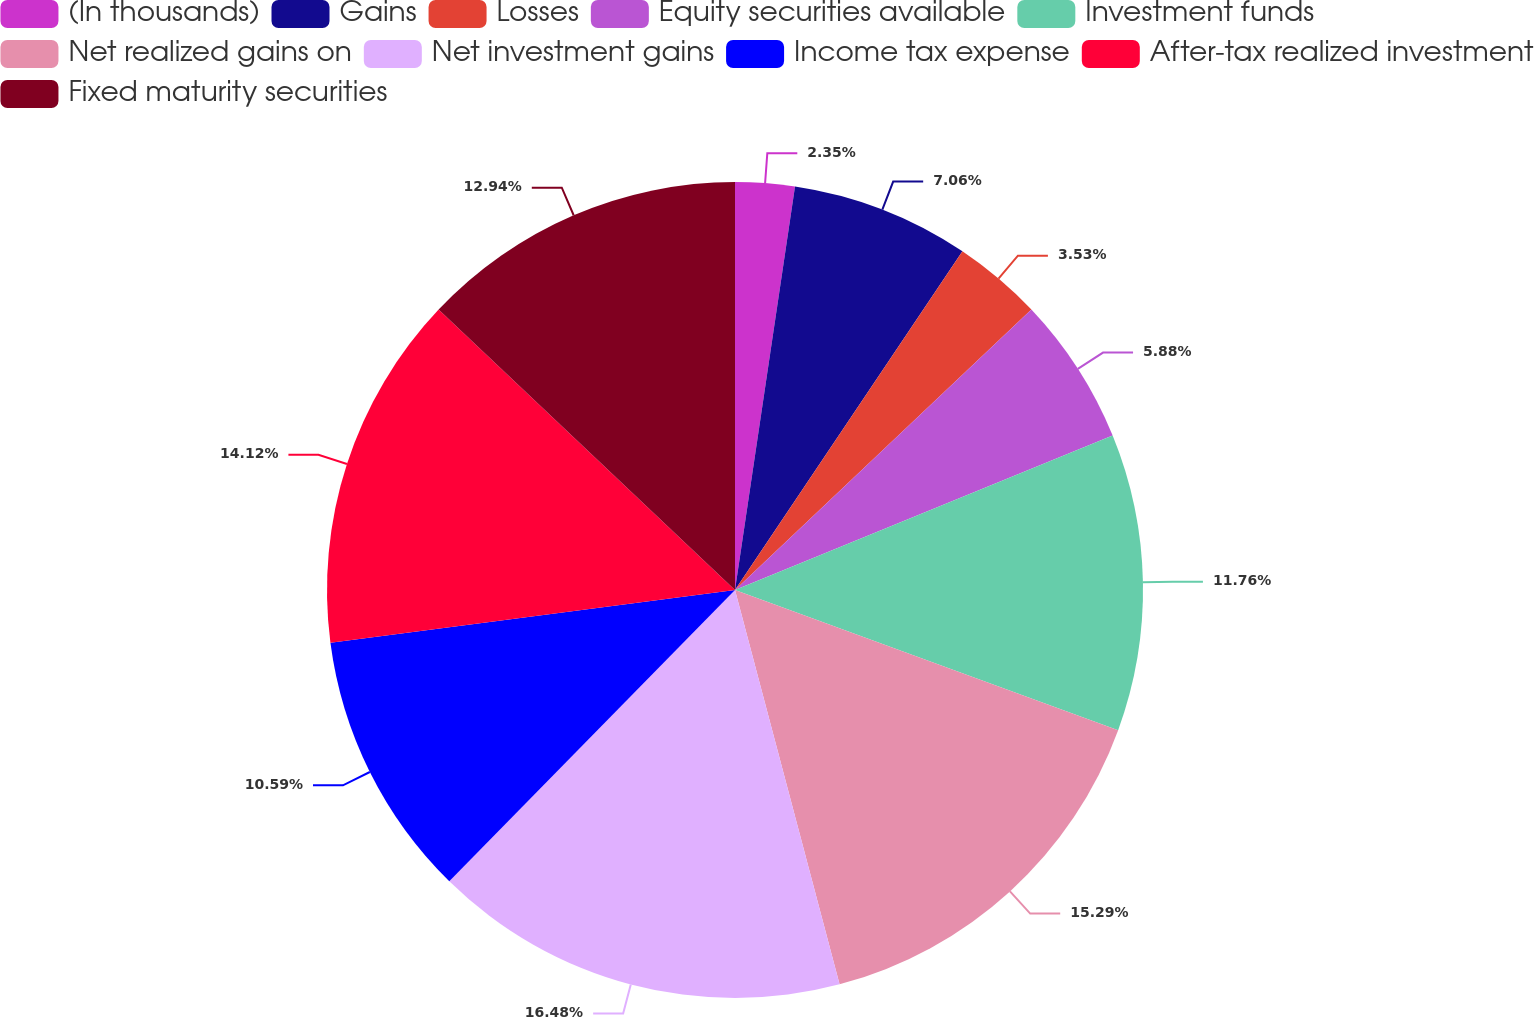Convert chart to OTSL. <chart><loc_0><loc_0><loc_500><loc_500><pie_chart><fcel>(In thousands)<fcel>Gains<fcel>Losses<fcel>Equity securities available<fcel>Investment funds<fcel>Net realized gains on<fcel>Net investment gains<fcel>Income tax expense<fcel>After-tax realized investment<fcel>Fixed maturity securities<nl><fcel>2.35%<fcel>7.06%<fcel>3.53%<fcel>5.88%<fcel>11.76%<fcel>15.29%<fcel>16.47%<fcel>10.59%<fcel>14.12%<fcel>12.94%<nl></chart> 